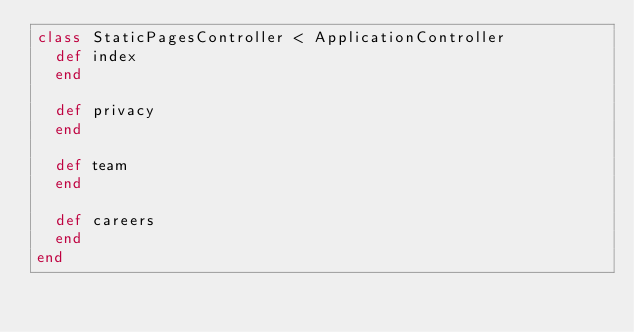Convert code to text. <code><loc_0><loc_0><loc_500><loc_500><_Ruby_>class StaticPagesController < ApplicationController
  def index    
  end

  def privacy
  end

  def team
  end

  def careers
  end
end
</code> 